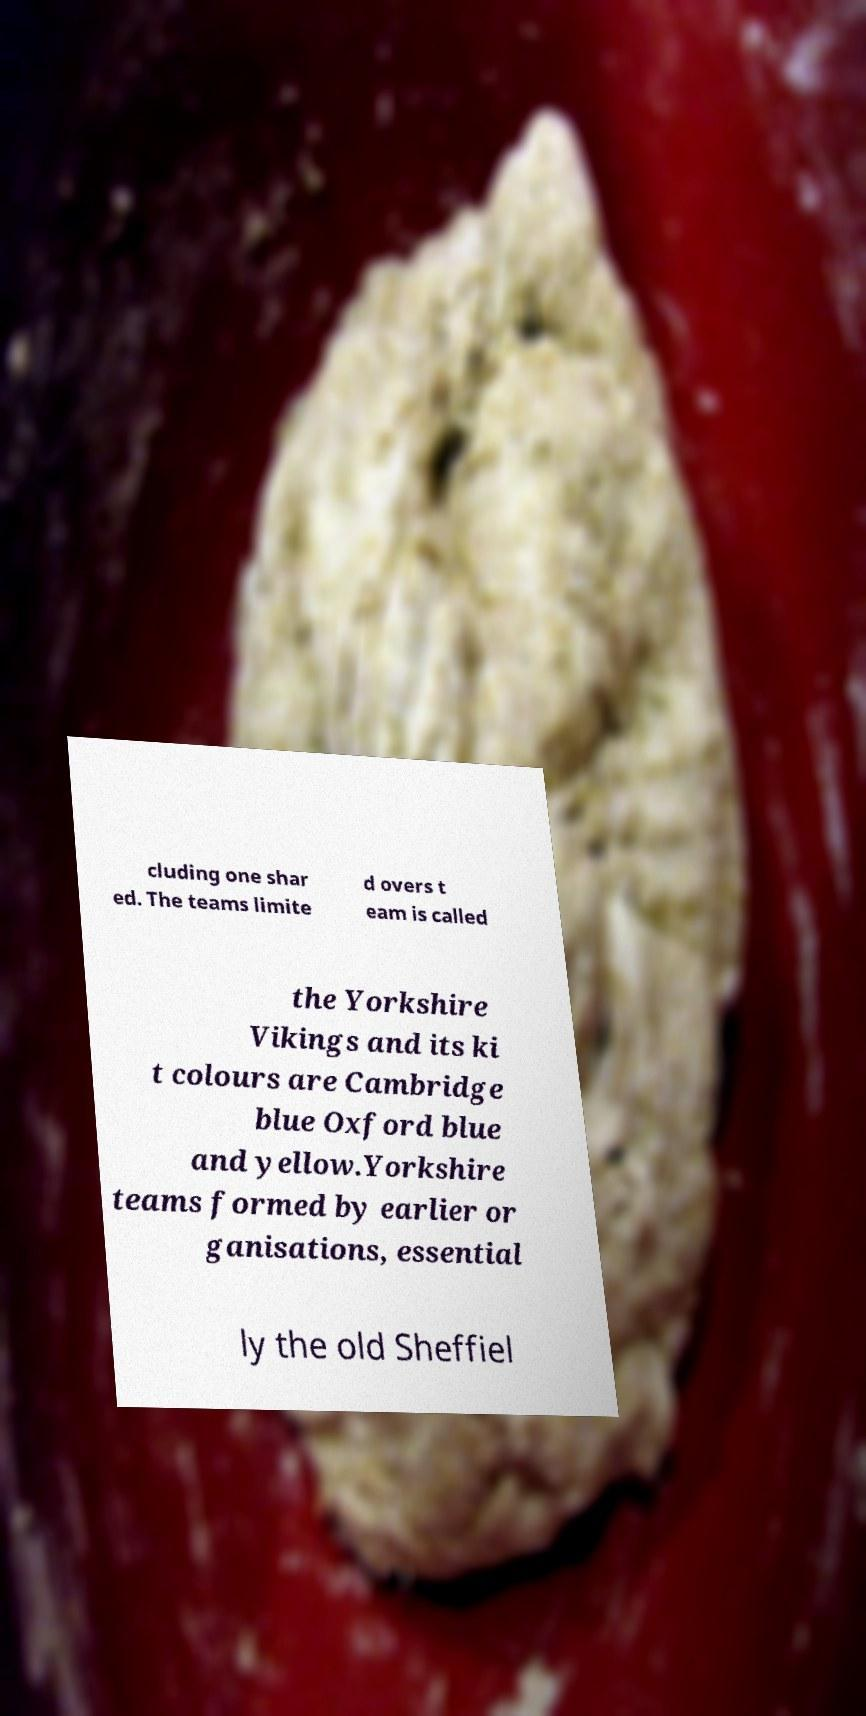I need the written content from this picture converted into text. Can you do that? cluding one shar ed. The teams limite d overs t eam is called the Yorkshire Vikings and its ki t colours are Cambridge blue Oxford blue and yellow.Yorkshire teams formed by earlier or ganisations, essential ly the old Sheffiel 